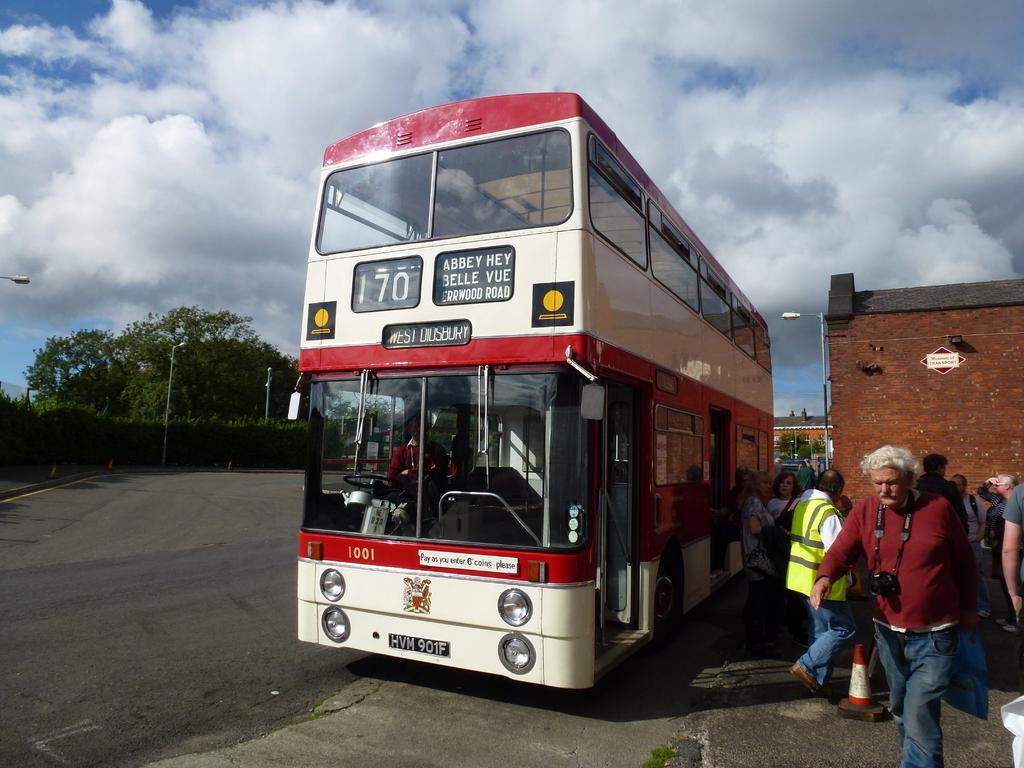<image>
Relay a brief, clear account of the picture shown. A red and white bus is number 170 and heading towards Abbey Hey, Belle Vue, and Errwood Road. 